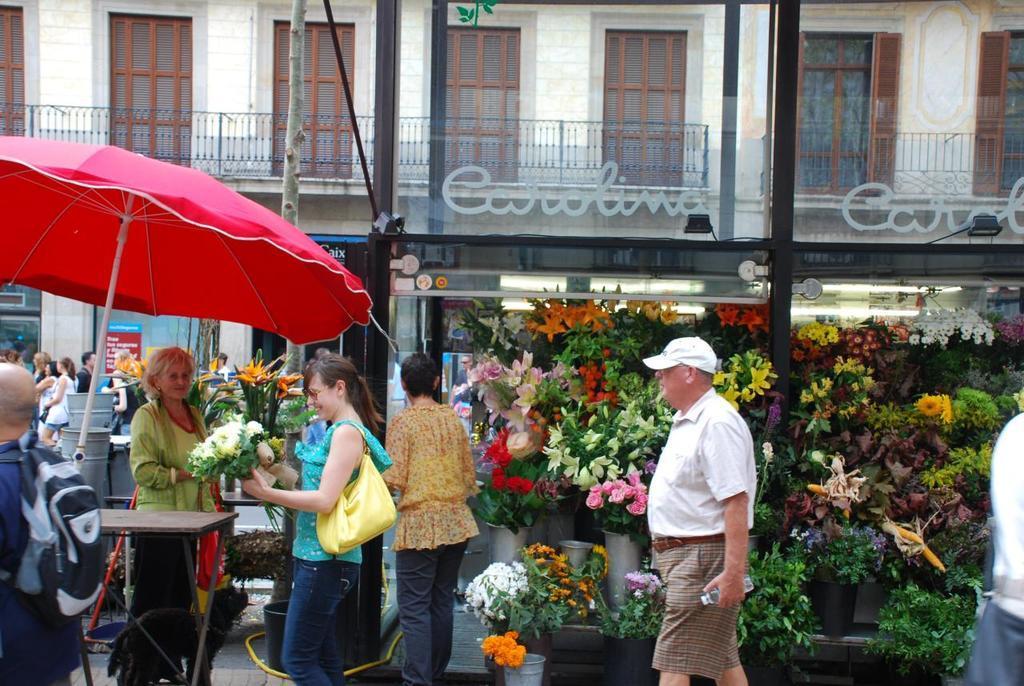In one or two sentences, can you explain what this image depicts? In this image we can see a few people, one lady is wearing a bag, she is holding a bouquet, another person is holding a bottle, there are some bouquets, lights, umbrella, wooden stick, there is a building, windows, there is a poster with some text on it, and there us a board with some text on it. 